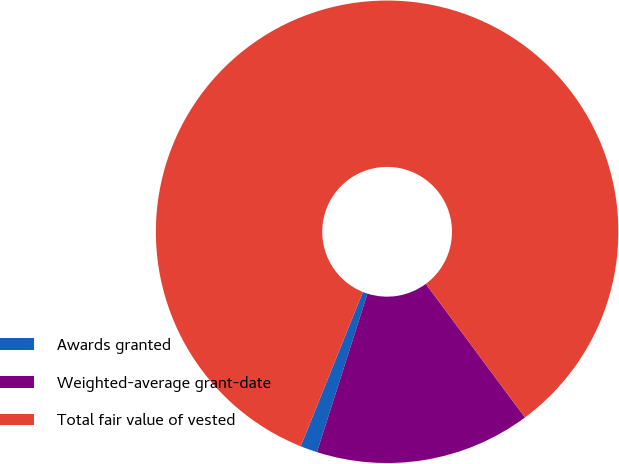Convert chart. <chart><loc_0><loc_0><loc_500><loc_500><pie_chart><fcel>Awards granted<fcel>Weighted-average grant-date<fcel>Total fair value of vested<nl><fcel>1.19%<fcel>15.07%<fcel>83.74%<nl></chart> 